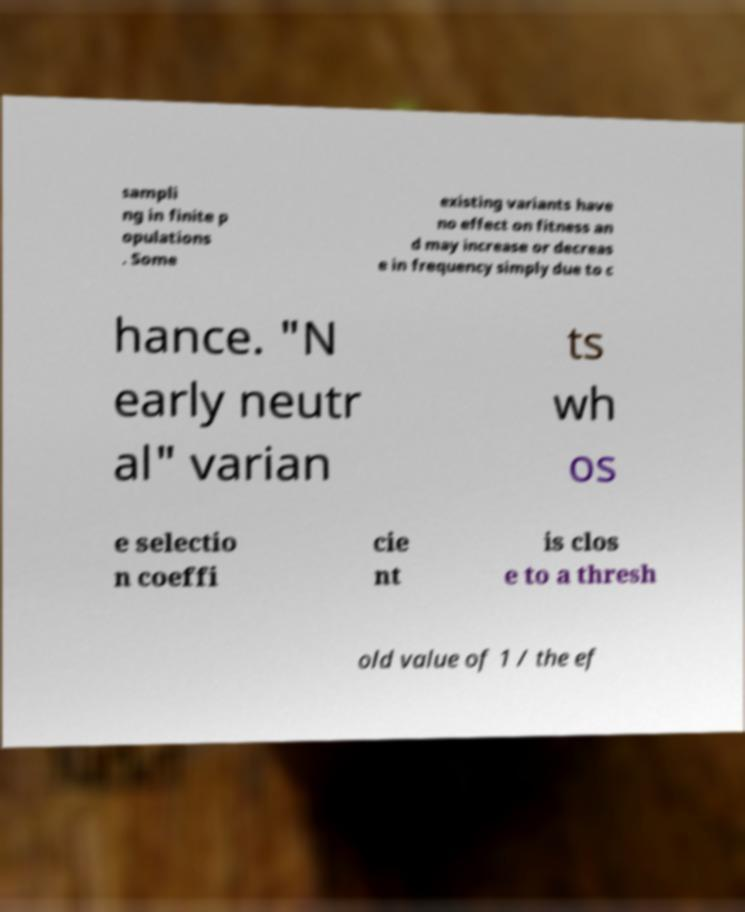For documentation purposes, I need the text within this image transcribed. Could you provide that? sampli ng in finite p opulations . Some existing variants have no effect on fitness an d may increase or decreas e in frequency simply due to c hance. "N early neutr al" varian ts wh os e selectio n coeffi cie nt is clos e to a thresh old value of 1 / the ef 